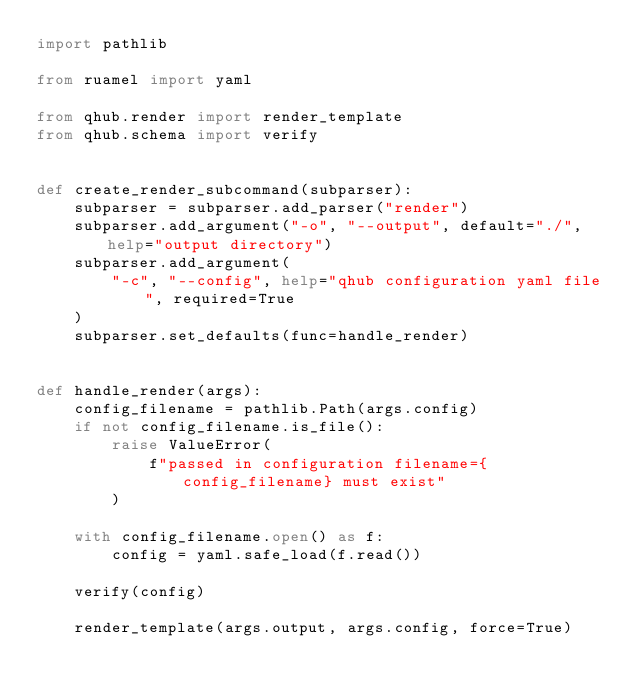<code> <loc_0><loc_0><loc_500><loc_500><_Python_>import pathlib

from ruamel import yaml

from qhub.render import render_template
from qhub.schema import verify


def create_render_subcommand(subparser):
    subparser = subparser.add_parser("render")
    subparser.add_argument("-o", "--output", default="./", help="output directory")
    subparser.add_argument(
        "-c", "--config", help="qhub configuration yaml file", required=True
    )
    subparser.set_defaults(func=handle_render)


def handle_render(args):
    config_filename = pathlib.Path(args.config)
    if not config_filename.is_file():
        raise ValueError(
            f"passed in configuration filename={config_filename} must exist"
        )

    with config_filename.open() as f:
        config = yaml.safe_load(f.read())

    verify(config)

    render_template(args.output, args.config, force=True)
</code> 